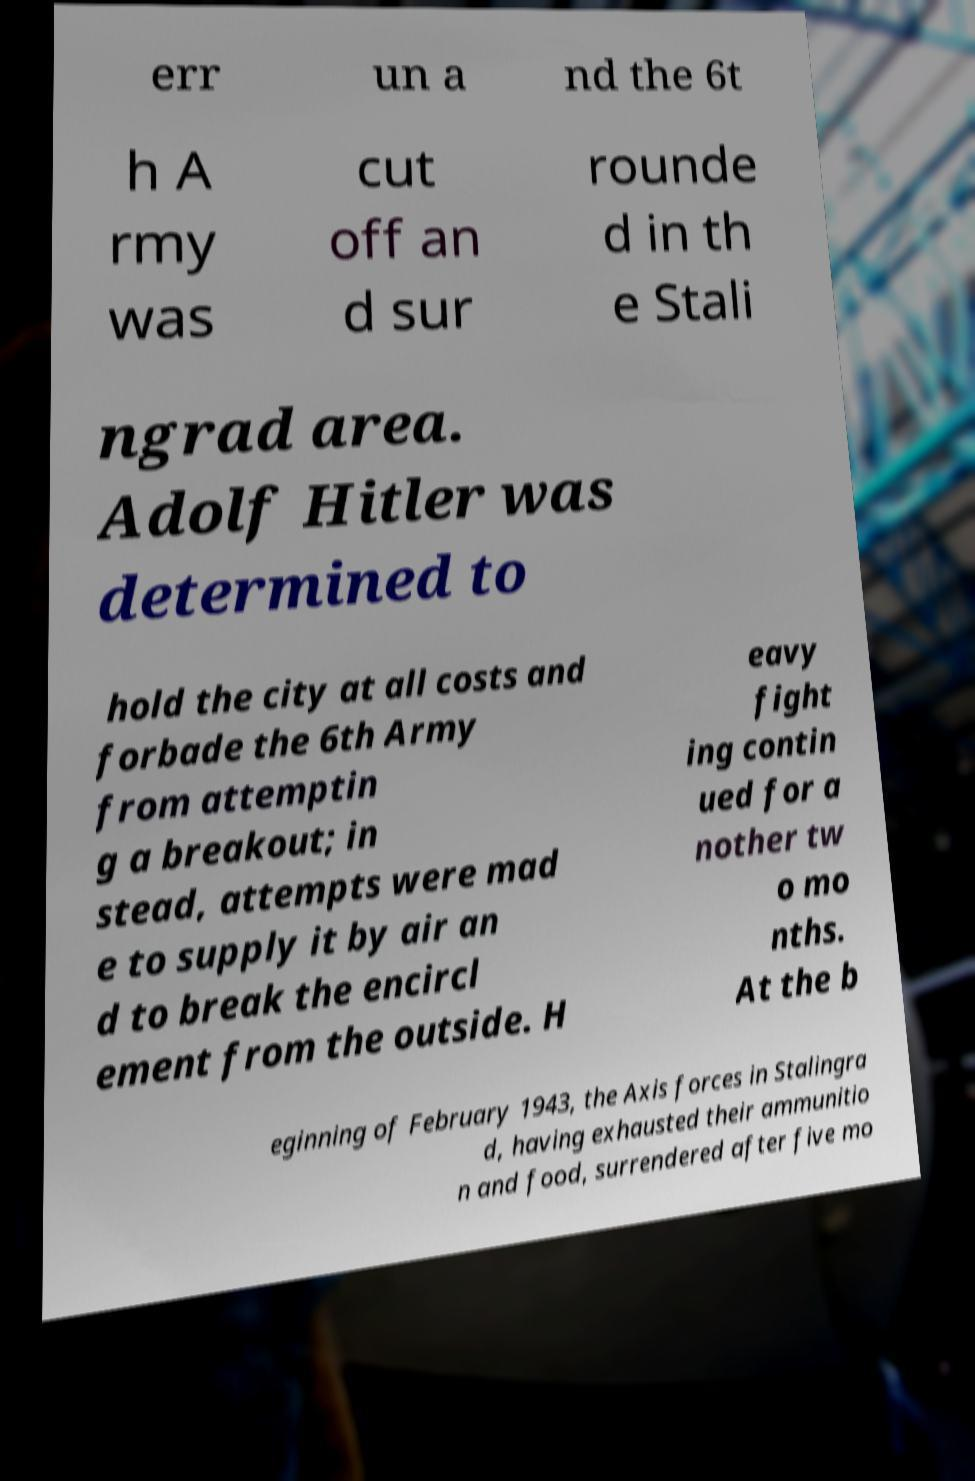Please read and relay the text visible in this image. What does it say? err un a nd the 6t h A rmy was cut off an d sur rounde d in th e Stali ngrad area. Adolf Hitler was determined to hold the city at all costs and forbade the 6th Army from attemptin g a breakout; in stead, attempts were mad e to supply it by air an d to break the encircl ement from the outside. H eavy fight ing contin ued for a nother tw o mo nths. At the b eginning of February 1943, the Axis forces in Stalingra d, having exhausted their ammunitio n and food, surrendered after five mo 